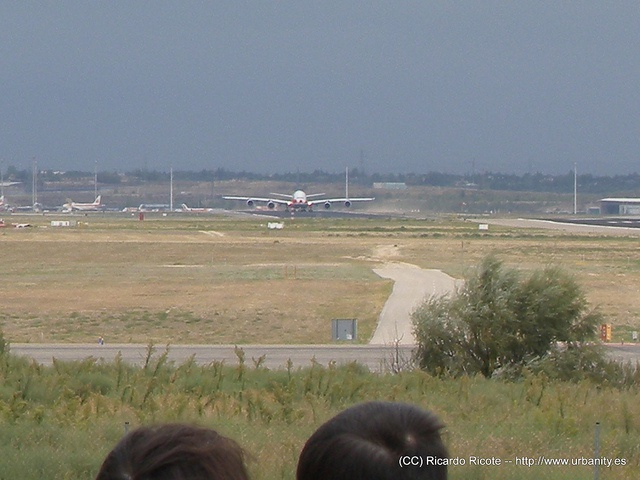Describe the objects in this image and their specific colors. I can see people in gray and black tones, people in gray and black tones, airplane in gray, lightgray, and darkgray tones, airplane in gray, darkgray, and lightgray tones, and airplane in gray and darkgray tones in this image. 